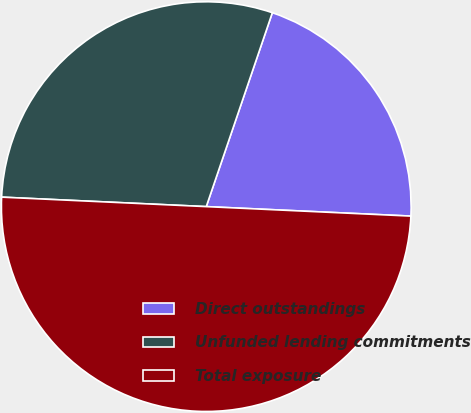Convert chart to OTSL. <chart><loc_0><loc_0><loc_500><loc_500><pie_chart><fcel>Direct outstandings<fcel>Unfunded lending commitments<fcel>Total exposure<nl><fcel>20.51%<fcel>29.49%<fcel>50.0%<nl></chart> 